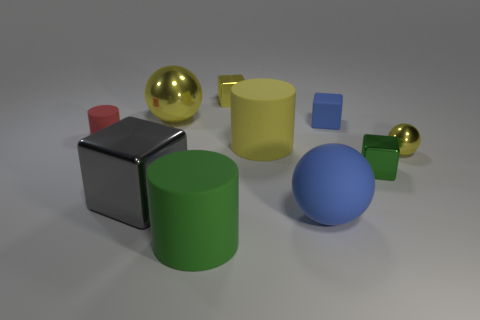Subtract all cubes. How many objects are left? 6 Add 9 tiny red rubber cylinders. How many tiny red rubber cylinders are left? 10 Add 9 blue balls. How many blue balls exist? 10 Subtract 1 yellow balls. How many objects are left? 9 Subtract all big red rubber spheres. Subtract all yellow blocks. How many objects are left? 9 